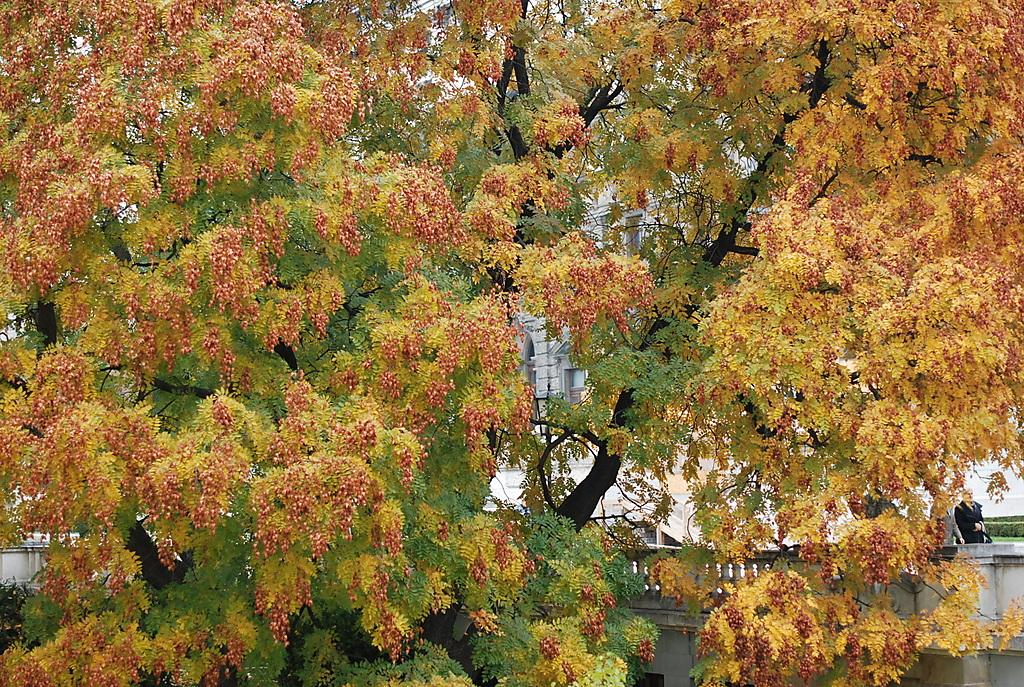What type of vegetation can be seen in the image? There are trees in the image. Can you describe the background of the image? There are people visible on a building in the background of the image. What type of breakfast is being served in the image? There is no breakfast visible in the image; it only features trees and people on a building. What type of amusement can be seen in the image? There is no amusement present in the image; it only features trees and people on a building. 